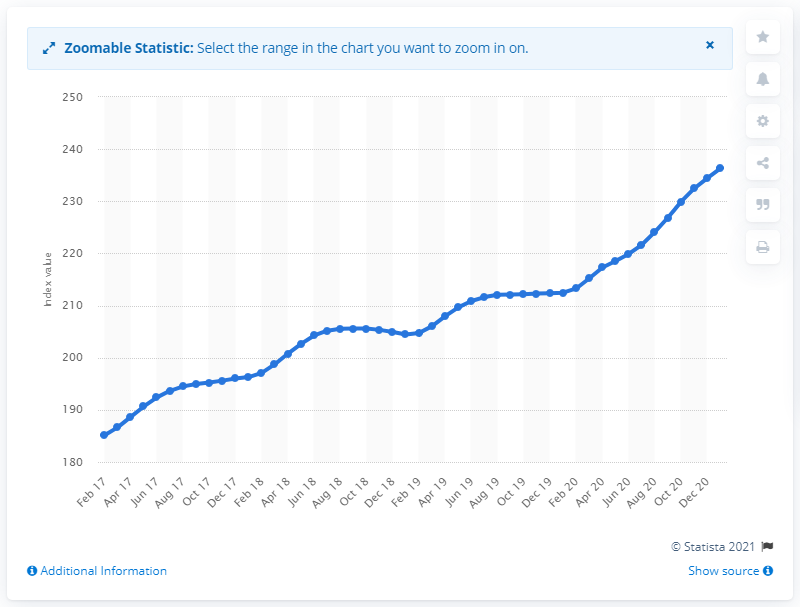Draw attention to some important aspects in this diagram. The value of the S&P Case Shiller National Home Price Index in January 2021 was 236.31. 